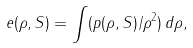<formula> <loc_0><loc_0><loc_500><loc_500>e ( \rho , S ) = \int ( p ( \rho , S ) / \rho ^ { 2 } ) \, d \rho ,</formula> 